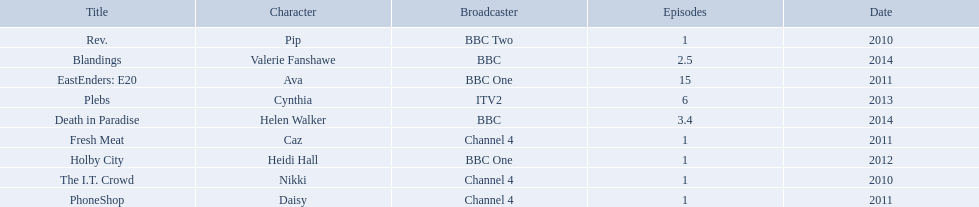Which characters were featured in more then one episode? Ava, Cynthia, Valerie Fanshawe, Helen Walker. Which of these were not in 2014? Ava, Cynthia. Which one of those was not on a bbc broadcaster? Cynthia. 